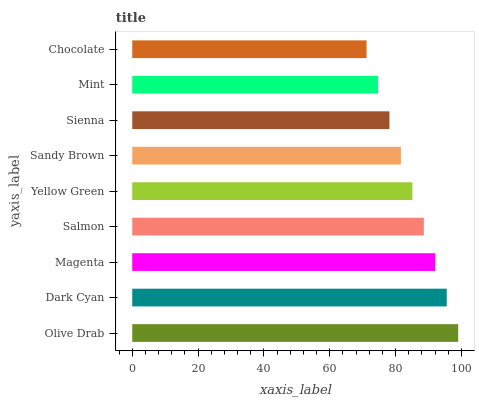Is Chocolate the minimum?
Answer yes or no. Yes. Is Olive Drab the maximum?
Answer yes or no. Yes. Is Dark Cyan the minimum?
Answer yes or no. No. Is Dark Cyan the maximum?
Answer yes or no. No. Is Olive Drab greater than Dark Cyan?
Answer yes or no. Yes. Is Dark Cyan less than Olive Drab?
Answer yes or no. Yes. Is Dark Cyan greater than Olive Drab?
Answer yes or no. No. Is Olive Drab less than Dark Cyan?
Answer yes or no. No. Is Yellow Green the high median?
Answer yes or no. Yes. Is Yellow Green the low median?
Answer yes or no. Yes. Is Dark Cyan the high median?
Answer yes or no. No. Is Sandy Brown the low median?
Answer yes or no. No. 